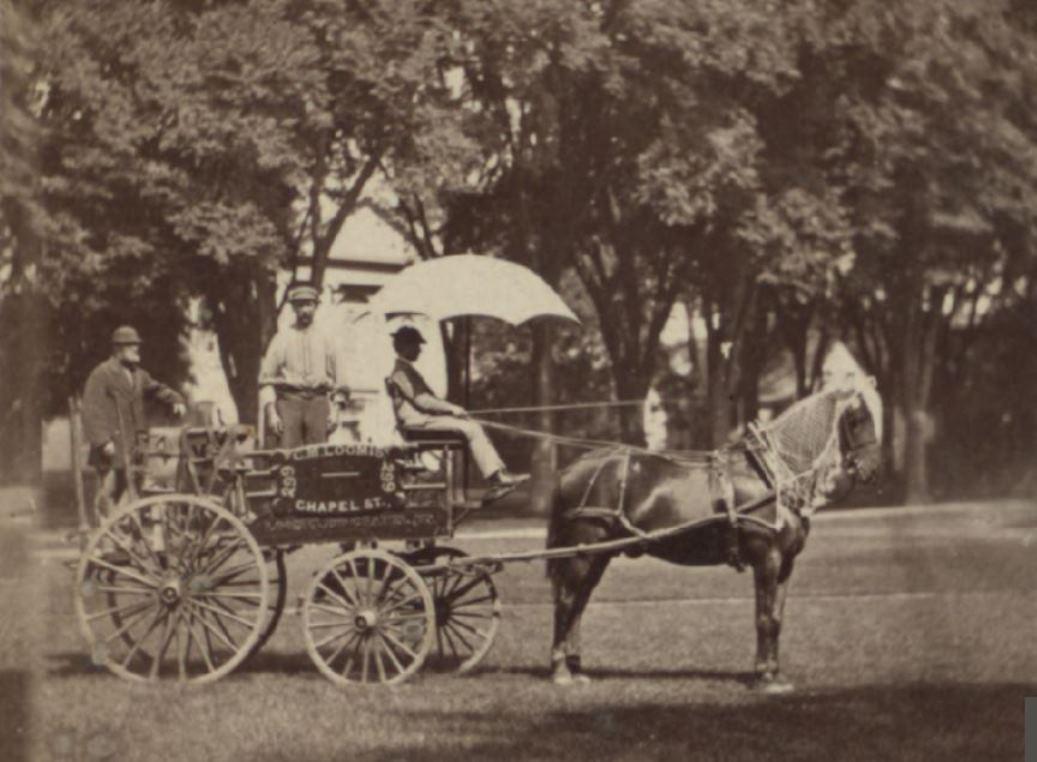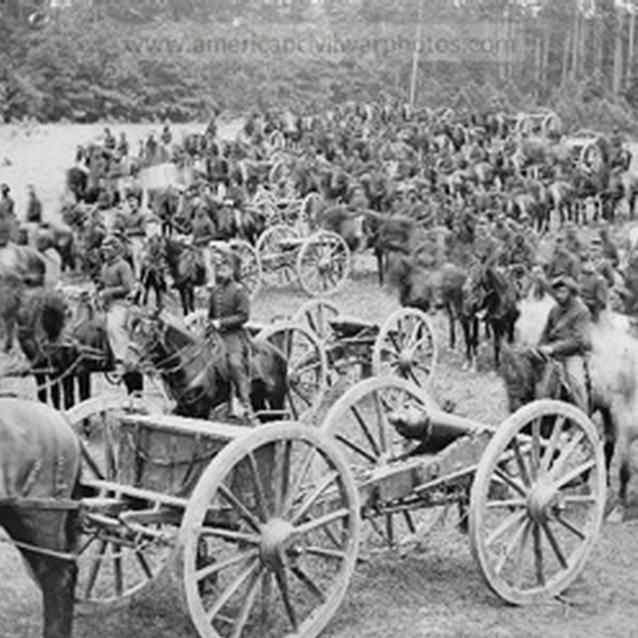The first image is the image on the left, the second image is the image on the right. Assess this claim about the two images: "A man sits on a horse wagon that has only 2 wheels.". Correct or not? Answer yes or no. No. 